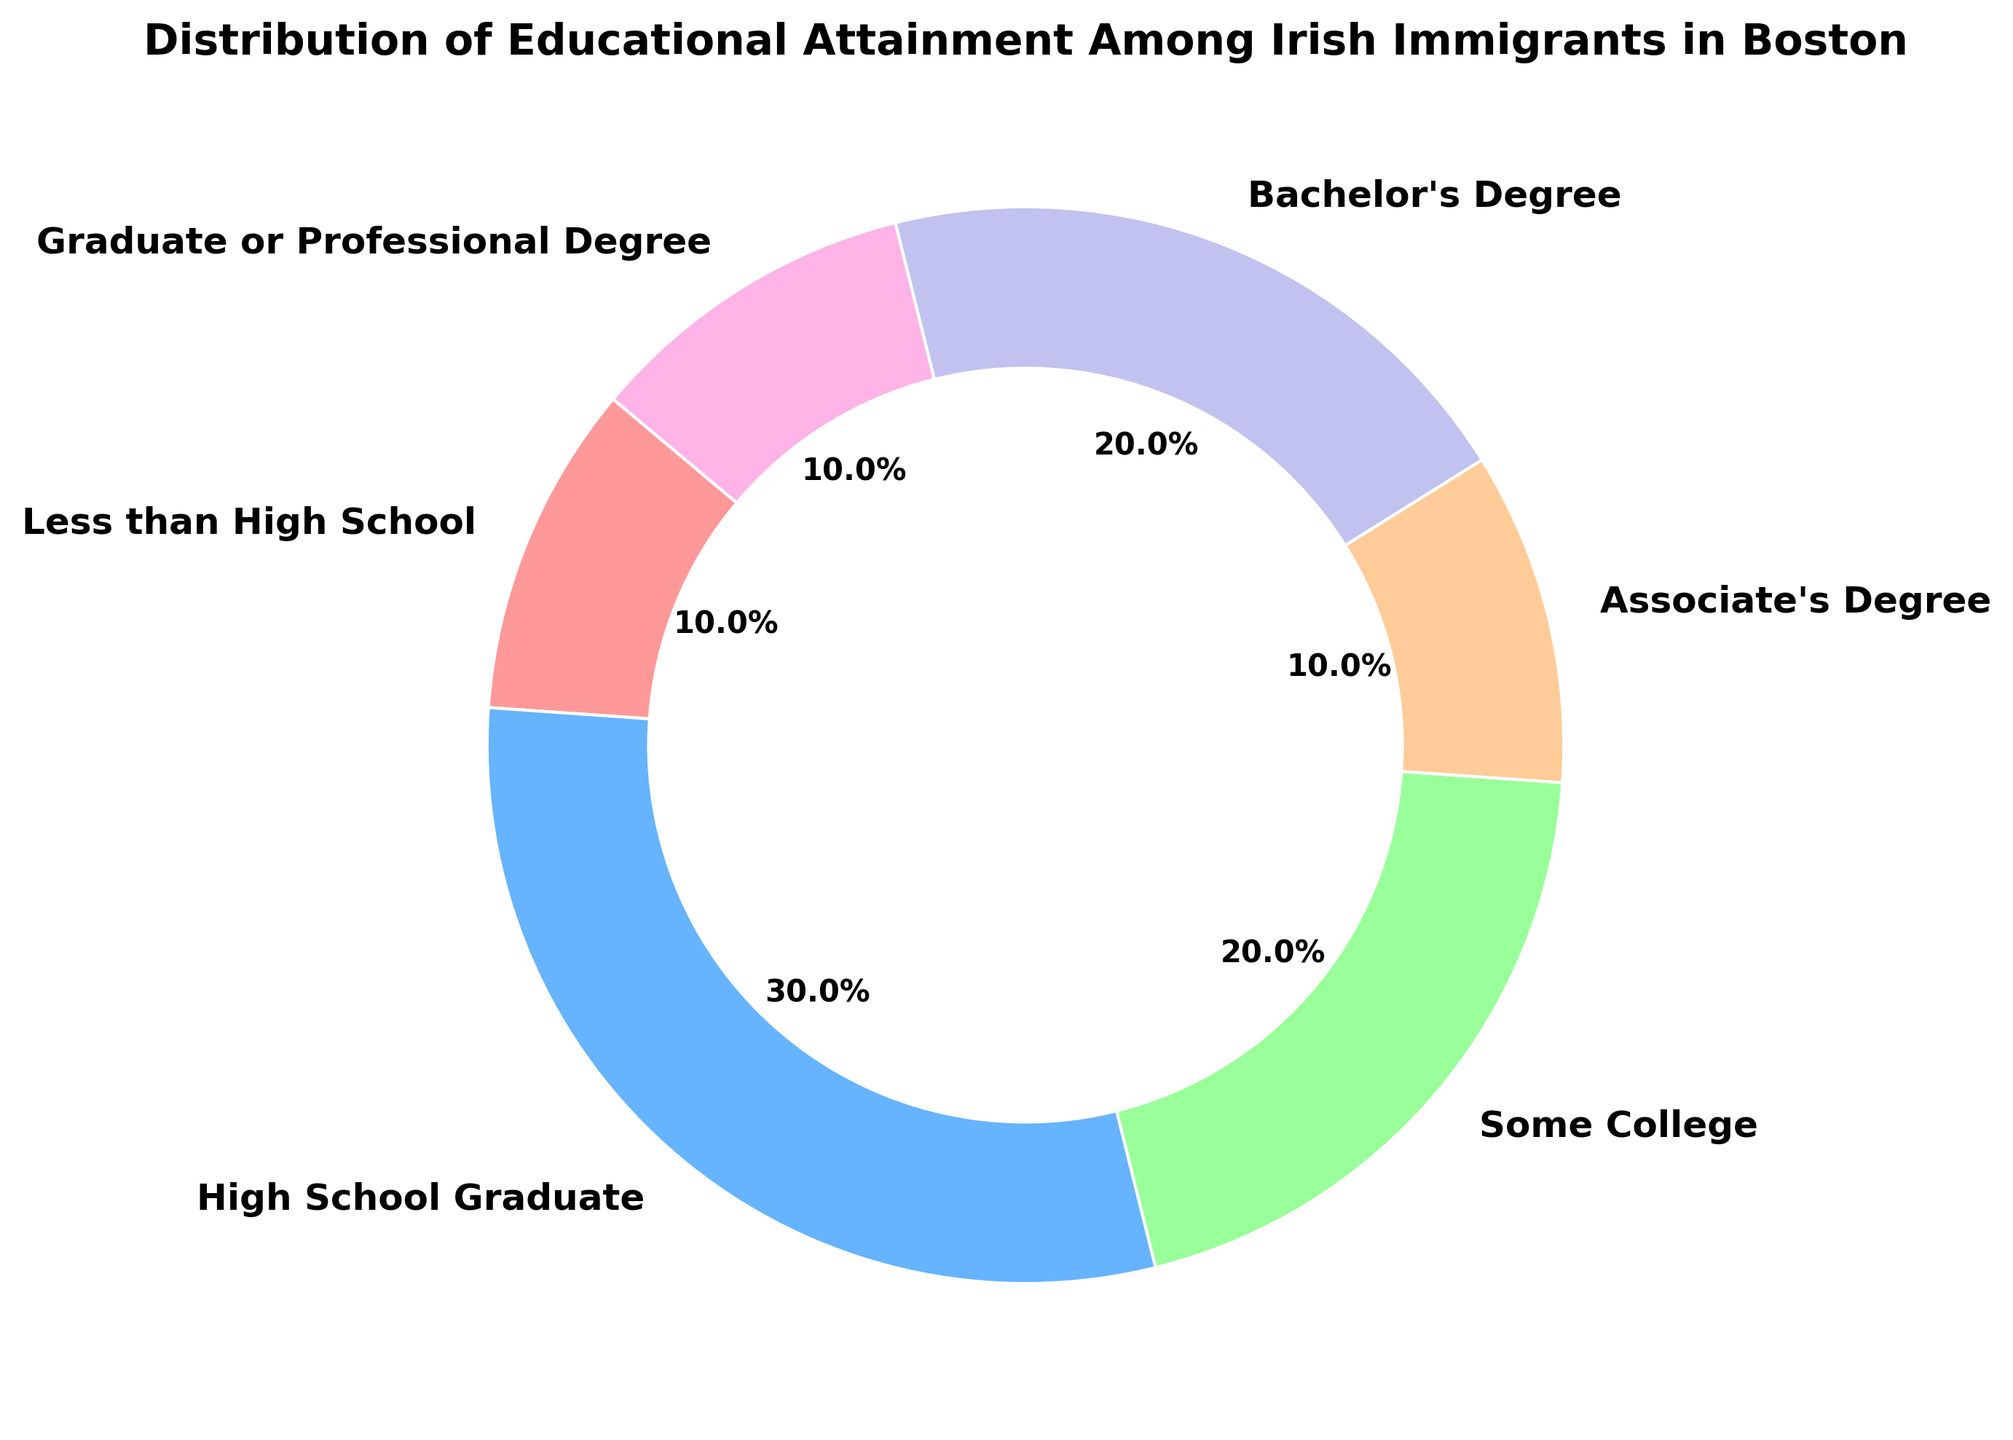What percentage of Irish immigrants in Boston have at least a Bachelor's Degree? To determine the percentage of those with at least a Bachelor's Degree, sum the percentages of Bachelor’s Degree holders and Graduate or Professional Degree holders (20% + 10%).
Answer: 30% What educational level has the smallest proportion among Irish immigrants in Boston? By examining the chart, we can see that "Less than High School", "Associate's Degree", and "Graduate or Professional Degree" each have the smallest percentage at 10%.
Answer: Less than High School, Associate's Degree, Graduate or Professional Degree Which educational attainment category has a higher percentage, High School Graduates or those with Some College? High School Graduates are represented by 30% while Some College is represented by 20%, so High School Graduates have a higher percentage.
Answer: High School Graduates Which segment is represented by the color blue in the distribution chart? Visually identify the segment colored blue, which corresponds to the High School Graduate category.
Answer: High School Graduate How many segments have an equal proportion in the chart? By examining the percentages, three segments have a proportion of 10% each — Less than High School, Associate's Degree, and Graduate or Professional Degree.
Answer: 3 segments What is the cumulative percentage for categories with less than 20% each? Sum the percentages of Less than High School (10%), Associate's Degree (10%), and Graduate or Professional Degree (10%), which total 30%.
Answer: 30% Is the proportion of Irish immigrants with a Bachelor's Degree greater than those with Some College but less than those who are High School Graduates? The percentage for Bachelor’s Degree is 20%, which is more than Some College (20%) and less than High School Graduate (30%).
Answer: Yes How many categories have more than 20% representation? Only High School Graduate (30%) surpasses 20%.
Answer: 1 category Which educational level is represented by the color green in the chart? Green corresponds to the category labeled as Some College.
Answer: Some College What percentage of immigrants have more than a High School education (including some college and beyond)? Sum the percentages of Some College (20%), Associate’s Degree (10%), Bachelor’s Degree (20%), and Graduate or Professional Degree (10%), which totals 60%.
Answer: 60% 